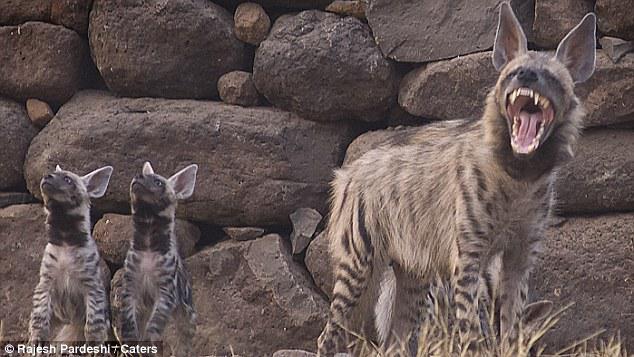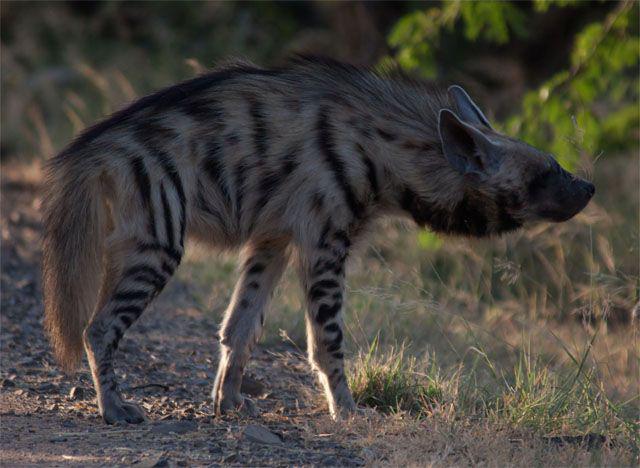The first image is the image on the left, the second image is the image on the right. For the images displayed, is the sentence "There is one baby hyena." factually correct? Answer yes or no. No. The first image is the image on the left, the second image is the image on the right. Given the left and right images, does the statement "there are at least three hyenas in the image on the left" hold true? Answer yes or no. Yes. 